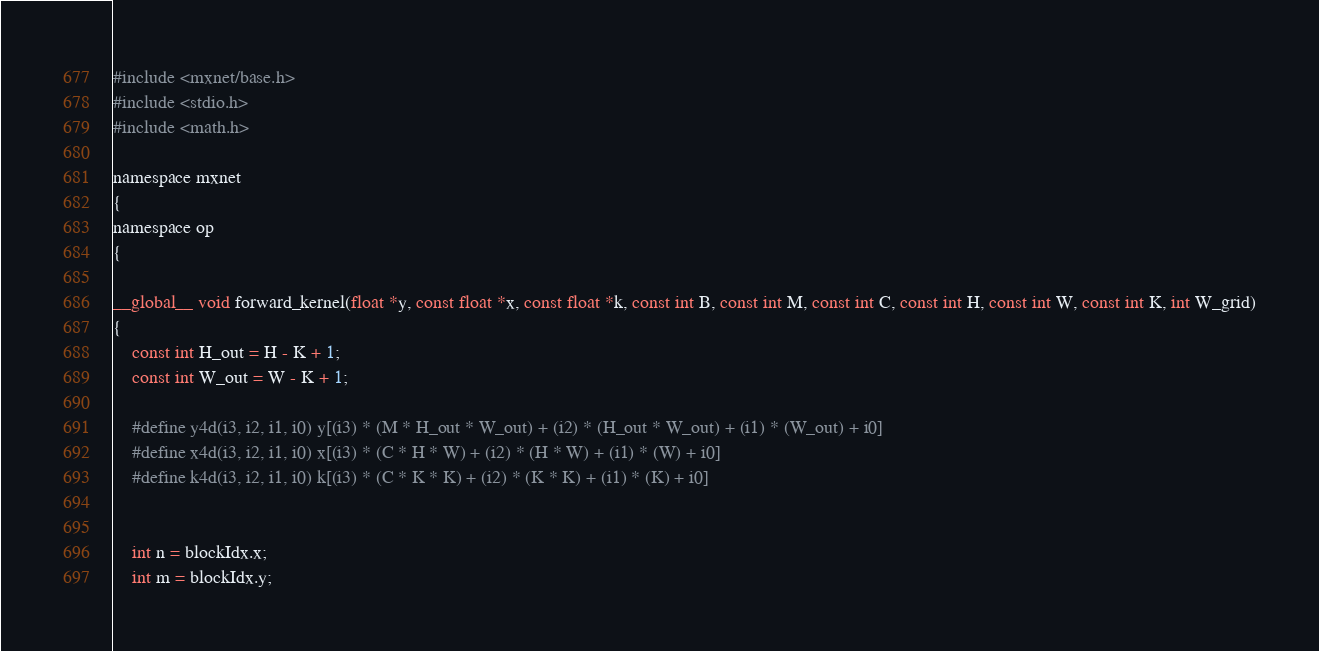Convert code to text. <code><loc_0><loc_0><loc_500><loc_500><_Cuda_>
#include <mxnet/base.h>
#include <stdio.h>
#include <math.h>

namespace mxnet
{
namespace op
{

__global__ void forward_kernel(float *y, const float *x, const float *k, const int B, const int M, const int C, const int H, const int W, const int K, int W_grid)
{
    const int H_out = H - K + 1;
    const int W_out = W - K + 1;

    #define y4d(i3, i2, i1, i0) y[(i3) * (M * H_out * W_out) + (i2) * (H_out * W_out) + (i1) * (W_out) + i0]
    #define x4d(i3, i2, i1, i0) x[(i3) * (C * H * W) + (i2) * (H * W) + (i1) * (W) + i0]
    #define k4d(i3, i2, i1, i0) k[(i3) * (C * K * K) + (i2) * (K * K) + (i1) * (K) + i0]


    int n = blockIdx.x;
    int m = blockIdx.y;</code> 